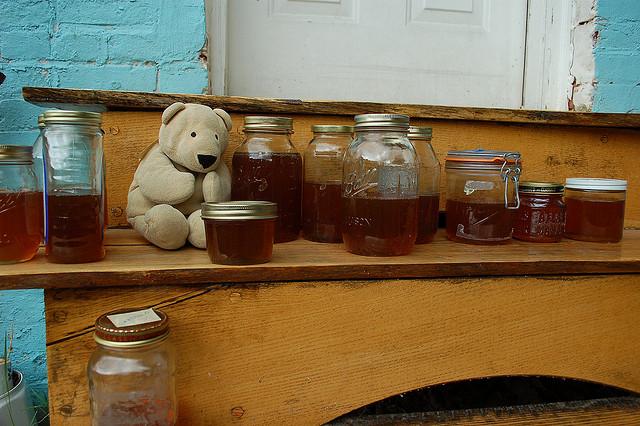Based on the stuffed animal, what is probably in these jars?
Quick response, please. Honey. Where are the jars?
Be succinct. On shelf. How many jars are there?
Concise answer only. 11. Could this honey be for sale?
Answer briefly. No. 